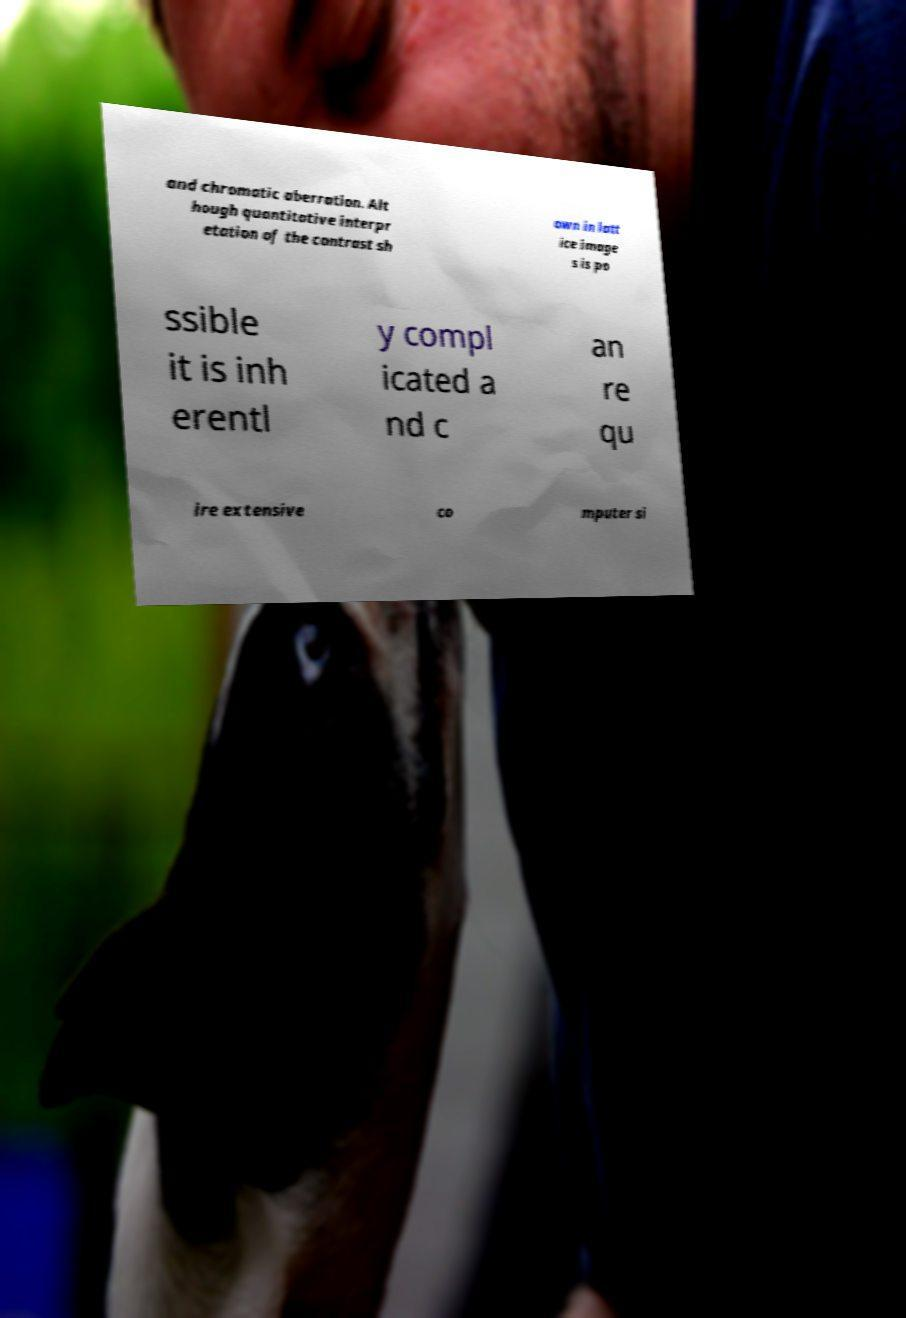What messages or text are displayed in this image? I need them in a readable, typed format. and chromatic aberration. Alt hough quantitative interpr etation of the contrast sh own in latt ice image s is po ssible it is inh erentl y compl icated a nd c an re qu ire extensive co mputer si 